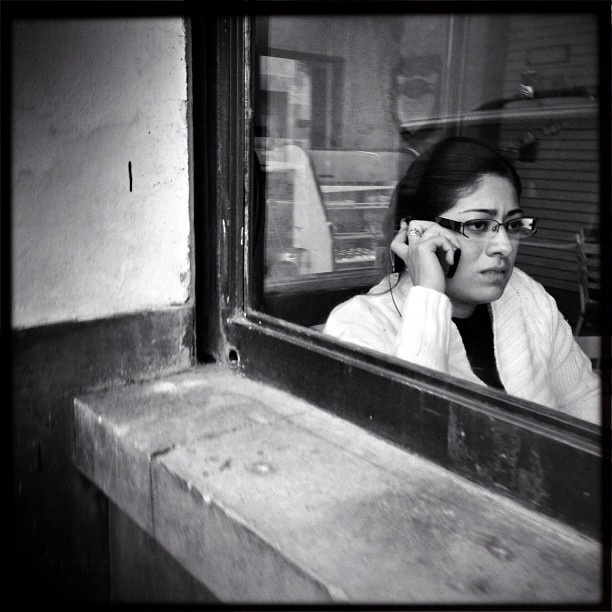Describe the objects in this image and their specific colors. I can see people in black, lightgray, darkgray, and gray tones and cell phone in black and gray tones in this image. 